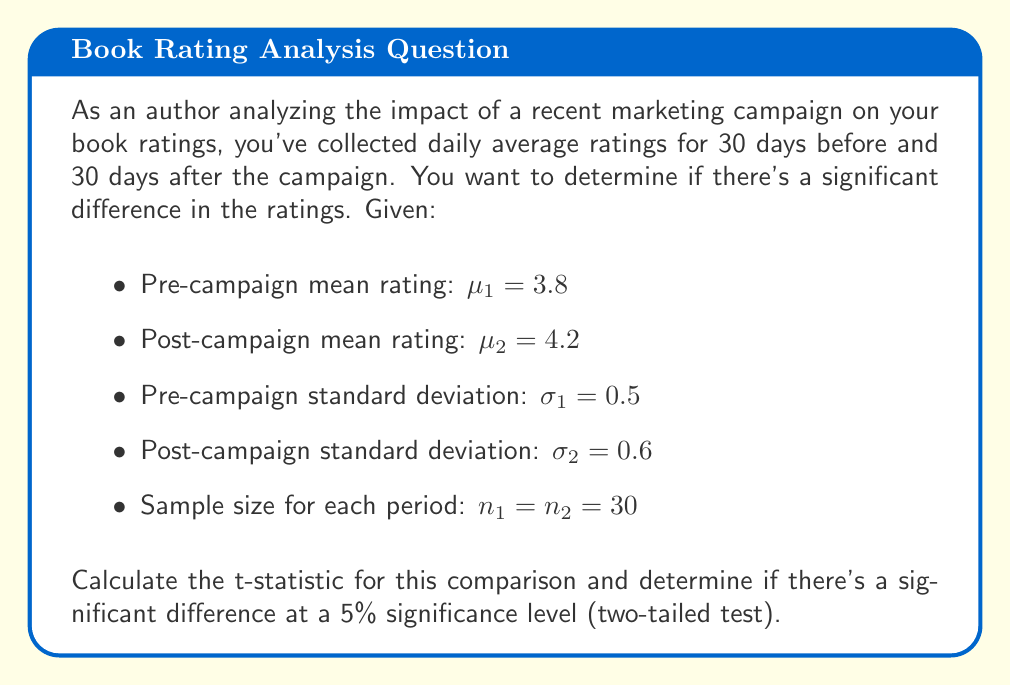Teach me how to tackle this problem. To evaluate the impact of the marketing campaign on book ratings, we'll use a two-sample t-test. The steps are as follows:

1. Calculate the pooled standard error:
   $$SE = \sqrt{\frac{\sigma_1^2}{n_1} + \frac{\sigma_2^2}{n_2}}$$
   $$SE = \sqrt{\frac{0.5^2}{30} + \frac{0.6^2}{30}} = \sqrt{0.0083 + 0.012} = \sqrt{0.0203} \approx 0.1425$$

2. Calculate the t-statistic:
   $$t = \frac{\mu_2 - \mu_1}{SE}$$
   $$t = \frac{4.2 - 3.8}{0.1425} \approx 2.807$$

3. Determine the degrees of freedom:
   $df = n_1 + n_2 - 2 = 30 + 30 - 2 = 58$

4. Find the critical t-value for a two-tailed test at 5% significance level:
   For $df = 58$ and $\alpha = 0.05$, the critical t-value is approximately $\pm 2.002$

5. Compare the calculated t-statistic with the critical t-value:
   Since $|2.807| > 2.002$, we reject the null hypothesis.

Therefore, there is a statistically significant difference in book ratings before and after the marketing campaign at the 5% significance level.
Answer: The t-statistic is approximately 2.807, which is greater than the critical value of 2.002. This indicates a statistically significant difference in book ratings before and after the marketing campaign at the 5% significance level. 